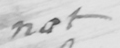Can you read and transcribe this handwriting? not 